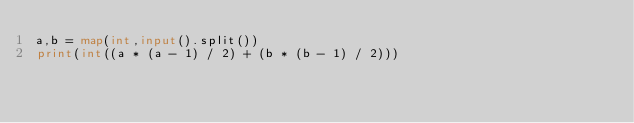<code> <loc_0><loc_0><loc_500><loc_500><_Python_>a,b = map(int,input().split())
print(int((a * (a - 1) / 2) + (b * (b - 1) / 2)))
</code> 